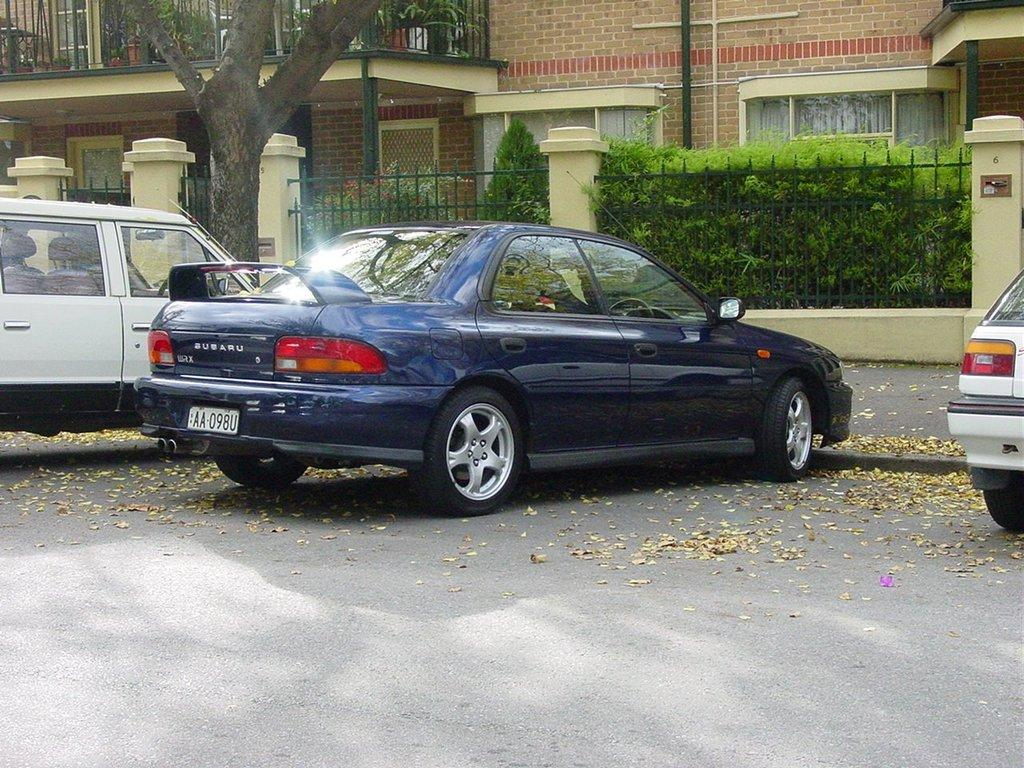What type of vehicles can be seen on the road in the image? There are cars on the road in the image. What is visible in the background of the image? There is a house, metal fencing, plants, and trees in the background of the image. What type of straw is being used to connect the pig to the fence in the image? There is no straw or pig present in the image. 